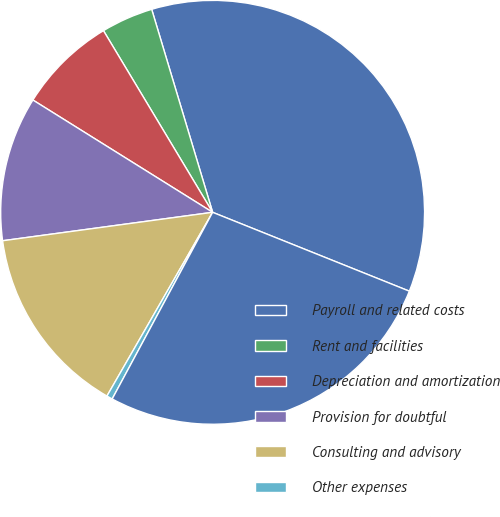Convert chart. <chart><loc_0><loc_0><loc_500><loc_500><pie_chart><fcel>Payroll and related costs<fcel>Rent and facilities<fcel>Depreciation and amortization<fcel>Provision for doubtful<fcel>Consulting and advisory<fcel>Other expenses<fcel>Total net increase (decrease)<nl><fcel>35.71%<fcel>3.97%<fcel>7.5%<fcel>11.03%<fcel>14.55%<fcel>0.45%<fcel>26.79%<nl></chart> 